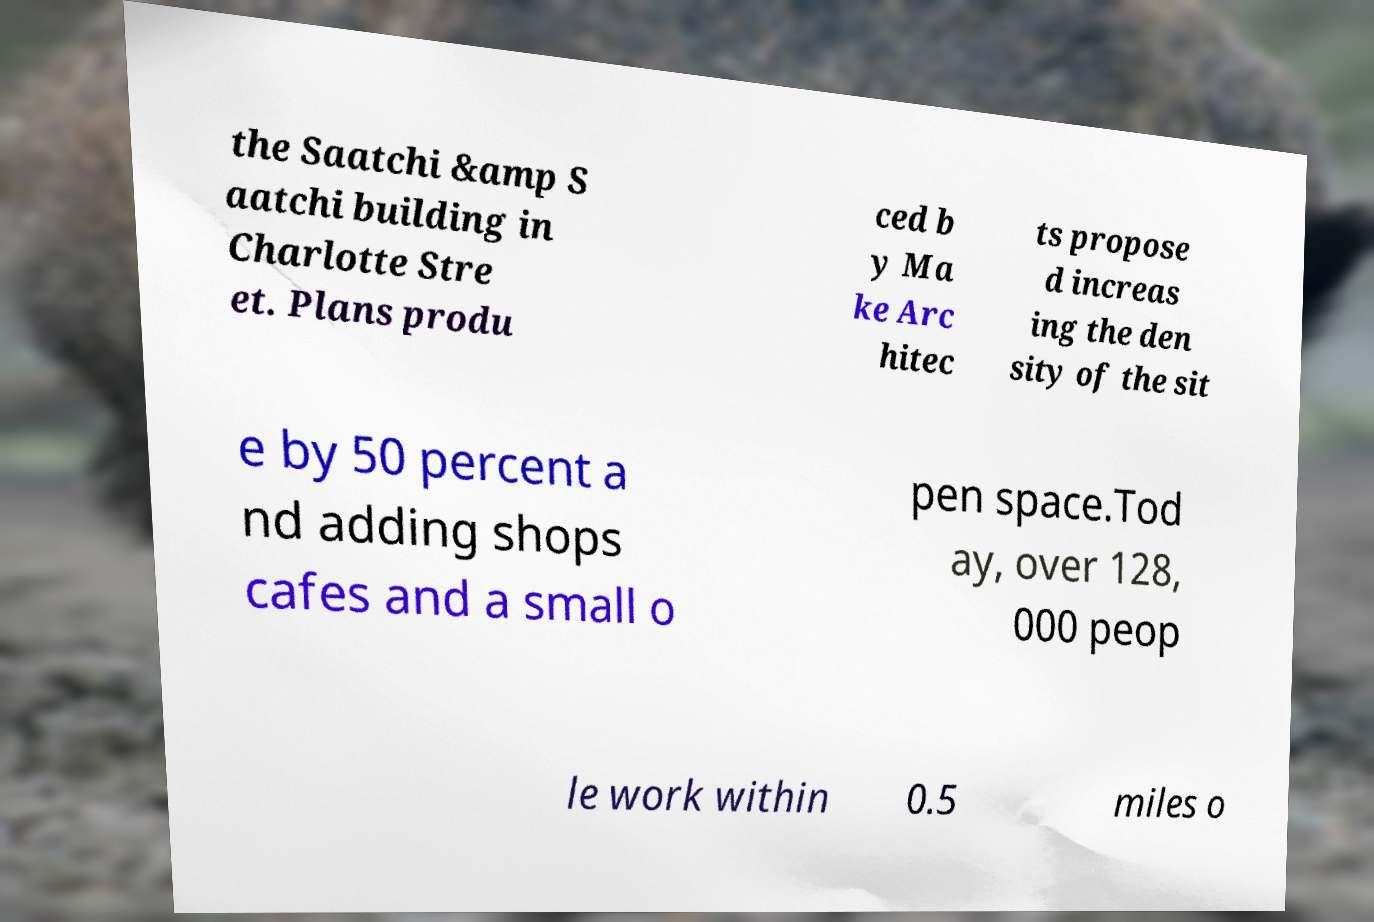Could you extract and type out the text from this image? the Saatchi &amp S aatchi building in Charlotte Stre et. Plans produ ced b y Ma ke Arc hitec ts propose d increas ing the den sity of the sit e by 50 percent a nd adding shops cafes and a small o pen space.Tod ay, over 128, 000 peop le work within 0.5 miles o 